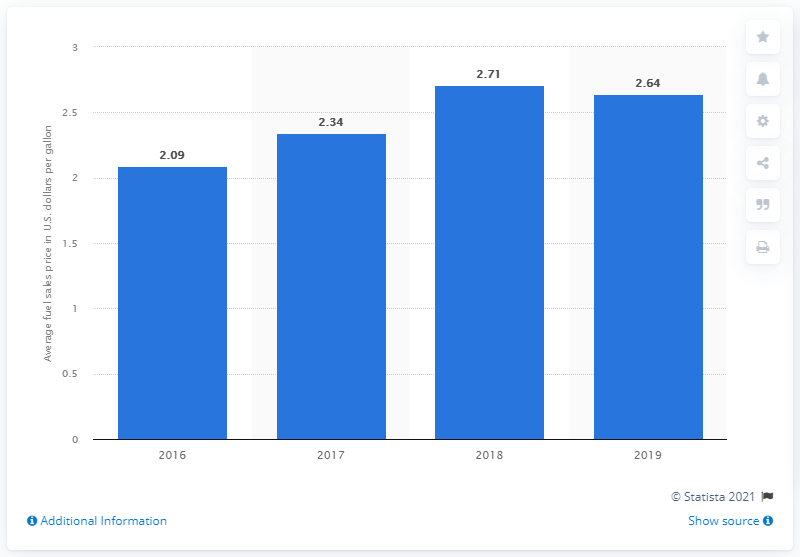Specify some key components in this picture. In 2018, the average fuel sales price of Speedway gas stations in the United States was 2.64 dollars per gallon. 